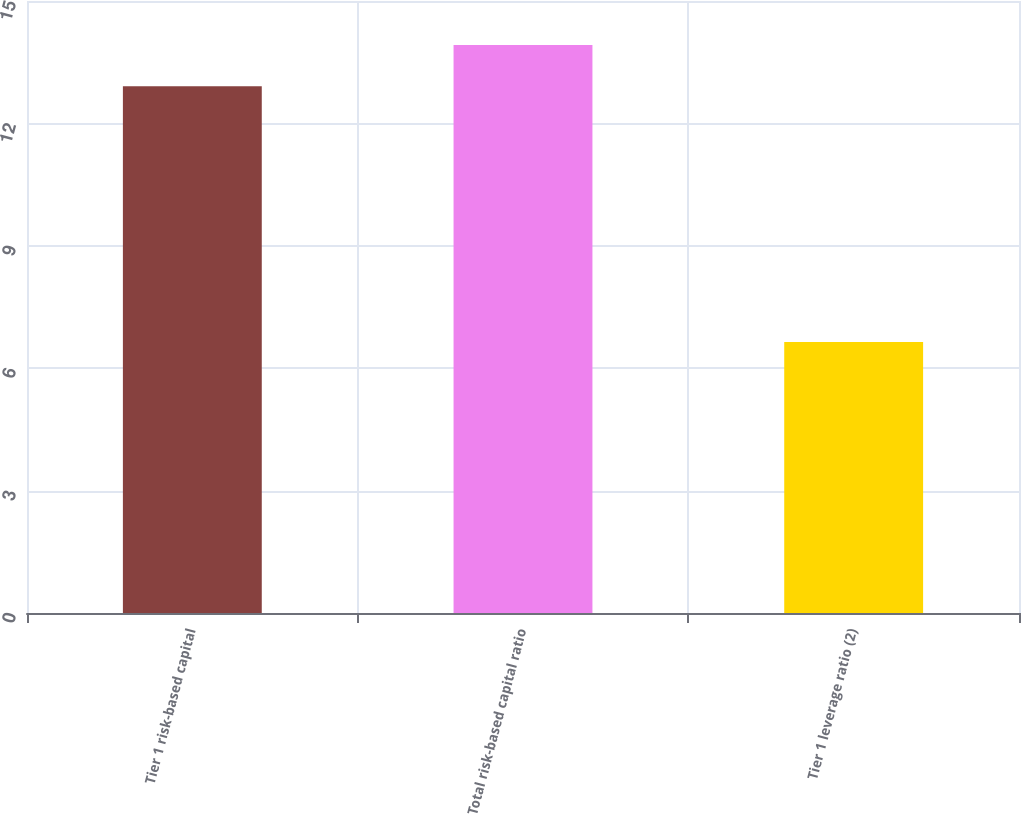<chart> <loc_0><loc_0><loc_500><loc_500><bar_chart><fcel>Tier 1 risk-based capital<fcel>Total risk-based capital ratio<fcel>Tier 1 leverage ratio (2)<nl><fcel>12.91<fcel>13.92<fcel>6.64<nl></chart> 